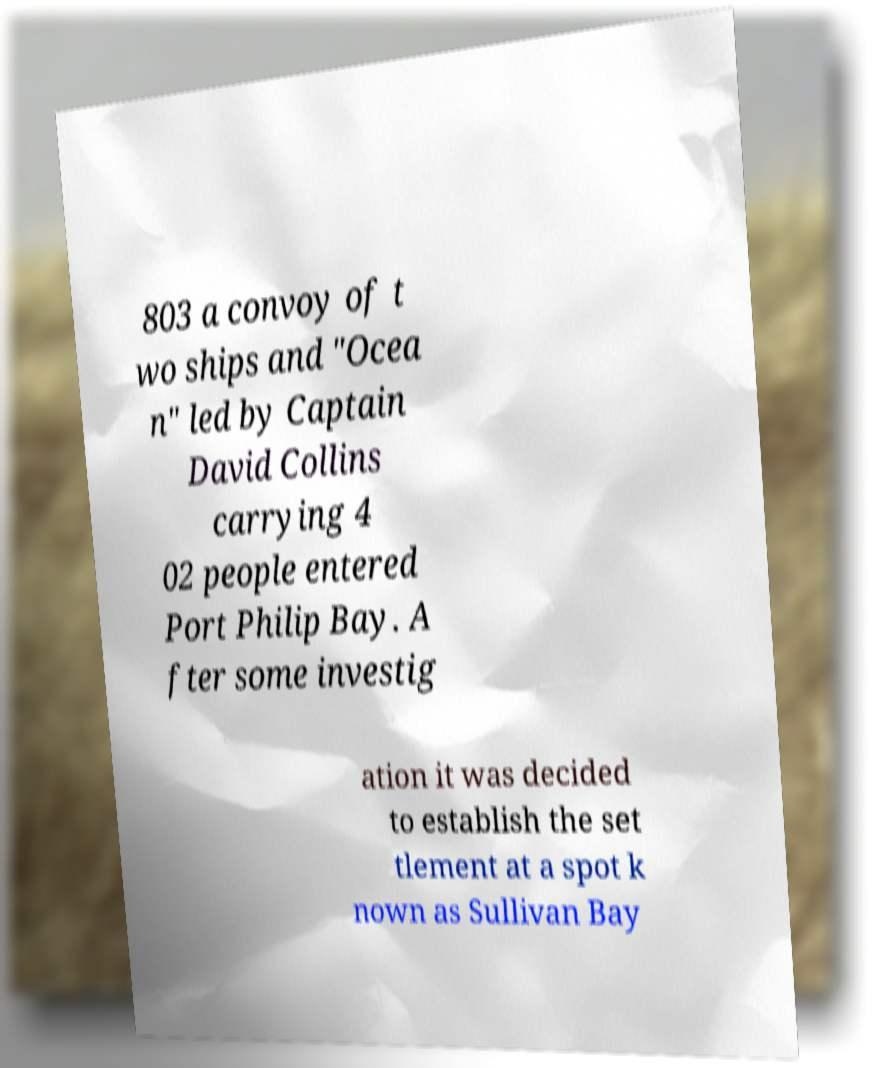Could you extract and type out the text from this image? 803 a convoy of t wo ships and "Ocea n" led by Captain David Collins carrying 4 02 people entered Port Philip Bay. A fter some investig ation it was decided to establish the set tlement at a spot k nown as Sullivan Bay 